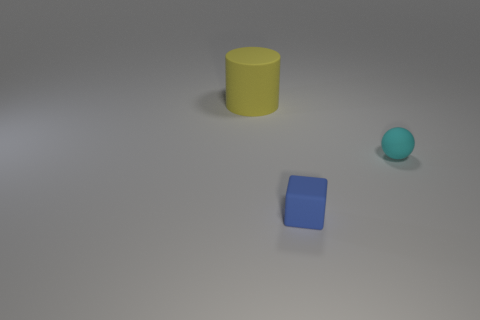Is the number of blue cylinders the same as the number of blue rubber things?
Make the answer very short. No. How many objects are both on the right side of the large yellow cylinder and on the left side of the small blue rubber object?
Make the answer very short. 0. What is the material of the small object that is to the right of the matte object that is in front of the object that is on the right side of the blue matte thing?
Your response must be concise. Rubber. How many blue cylinders are the same material as the big yellow cylinder?
Your answer should be compact. 0. What is the shape of the blue object that is the same size as the cyan rubber sphere?
Give a very brief answer. Cube. There is a big yellow matte cylinder; are there any small blue rubber blocks to the left of it?
Ensure brevity in your answer.  No. Are there any blue objects that have the same shape as the big yellow thing?
Your response must be concise. No. There is a object that is on the left side of the blue block; is its shape the same as the small object that is in front of the small cyan ball?
Give a very brief answer. No. Is there another blue matte cube that has the same size as the rubber block?
Make the answer very short. No. Are there the same number of big yellow matte objects that are behind the small blue rubber object and cyan rubber things that are in front of the tiny cyan sphere?
Provide a succinct answer. No. 